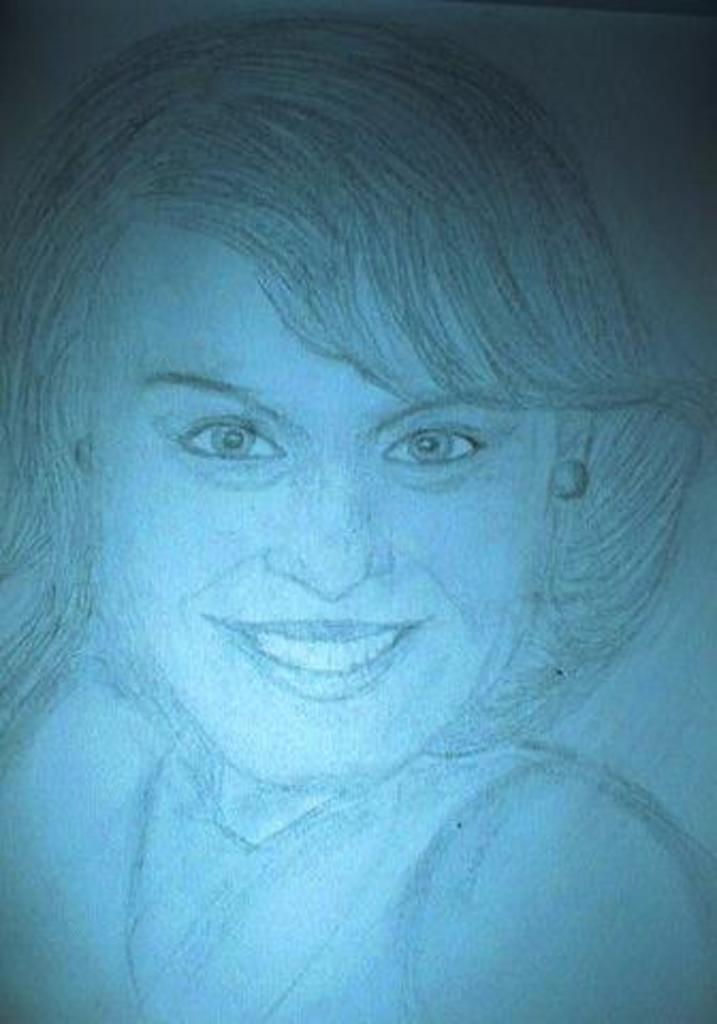What is the main subject of the image? There is a sketch of a person in the image. What color is the foot of the person in the image? There is no foot visible in the image, as it is a sketch of a person and not a photograph or realistic depiction. 